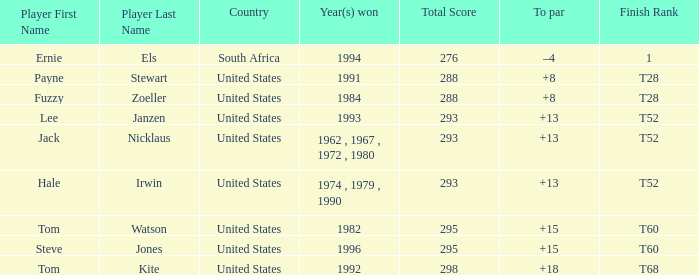Who is the player who won in 1994? Ernie Els. 